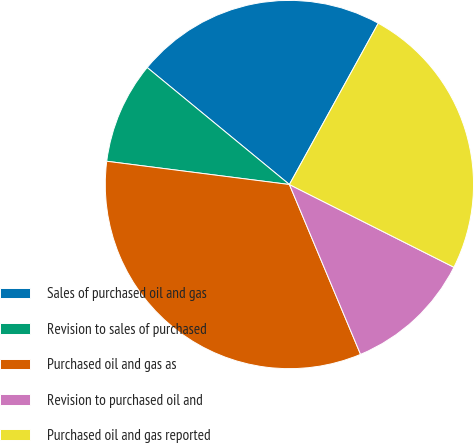Convert chart to OTSL. <chart><loc_0><loc_0><loc_500><loc_500><pie_chart><fcel>Sales of purchased oil and gas<fcel>Revision to sales of purchased<fcel>Purchased oil and gas as<fcel>Revision to purchased oil and<fcel>Purchased oil and gas reported<nl><fcel>22.06%<fcel>8.94%<fcel>33.33%<fcel>11.27%<fcel>24.4%<nl></chart> 